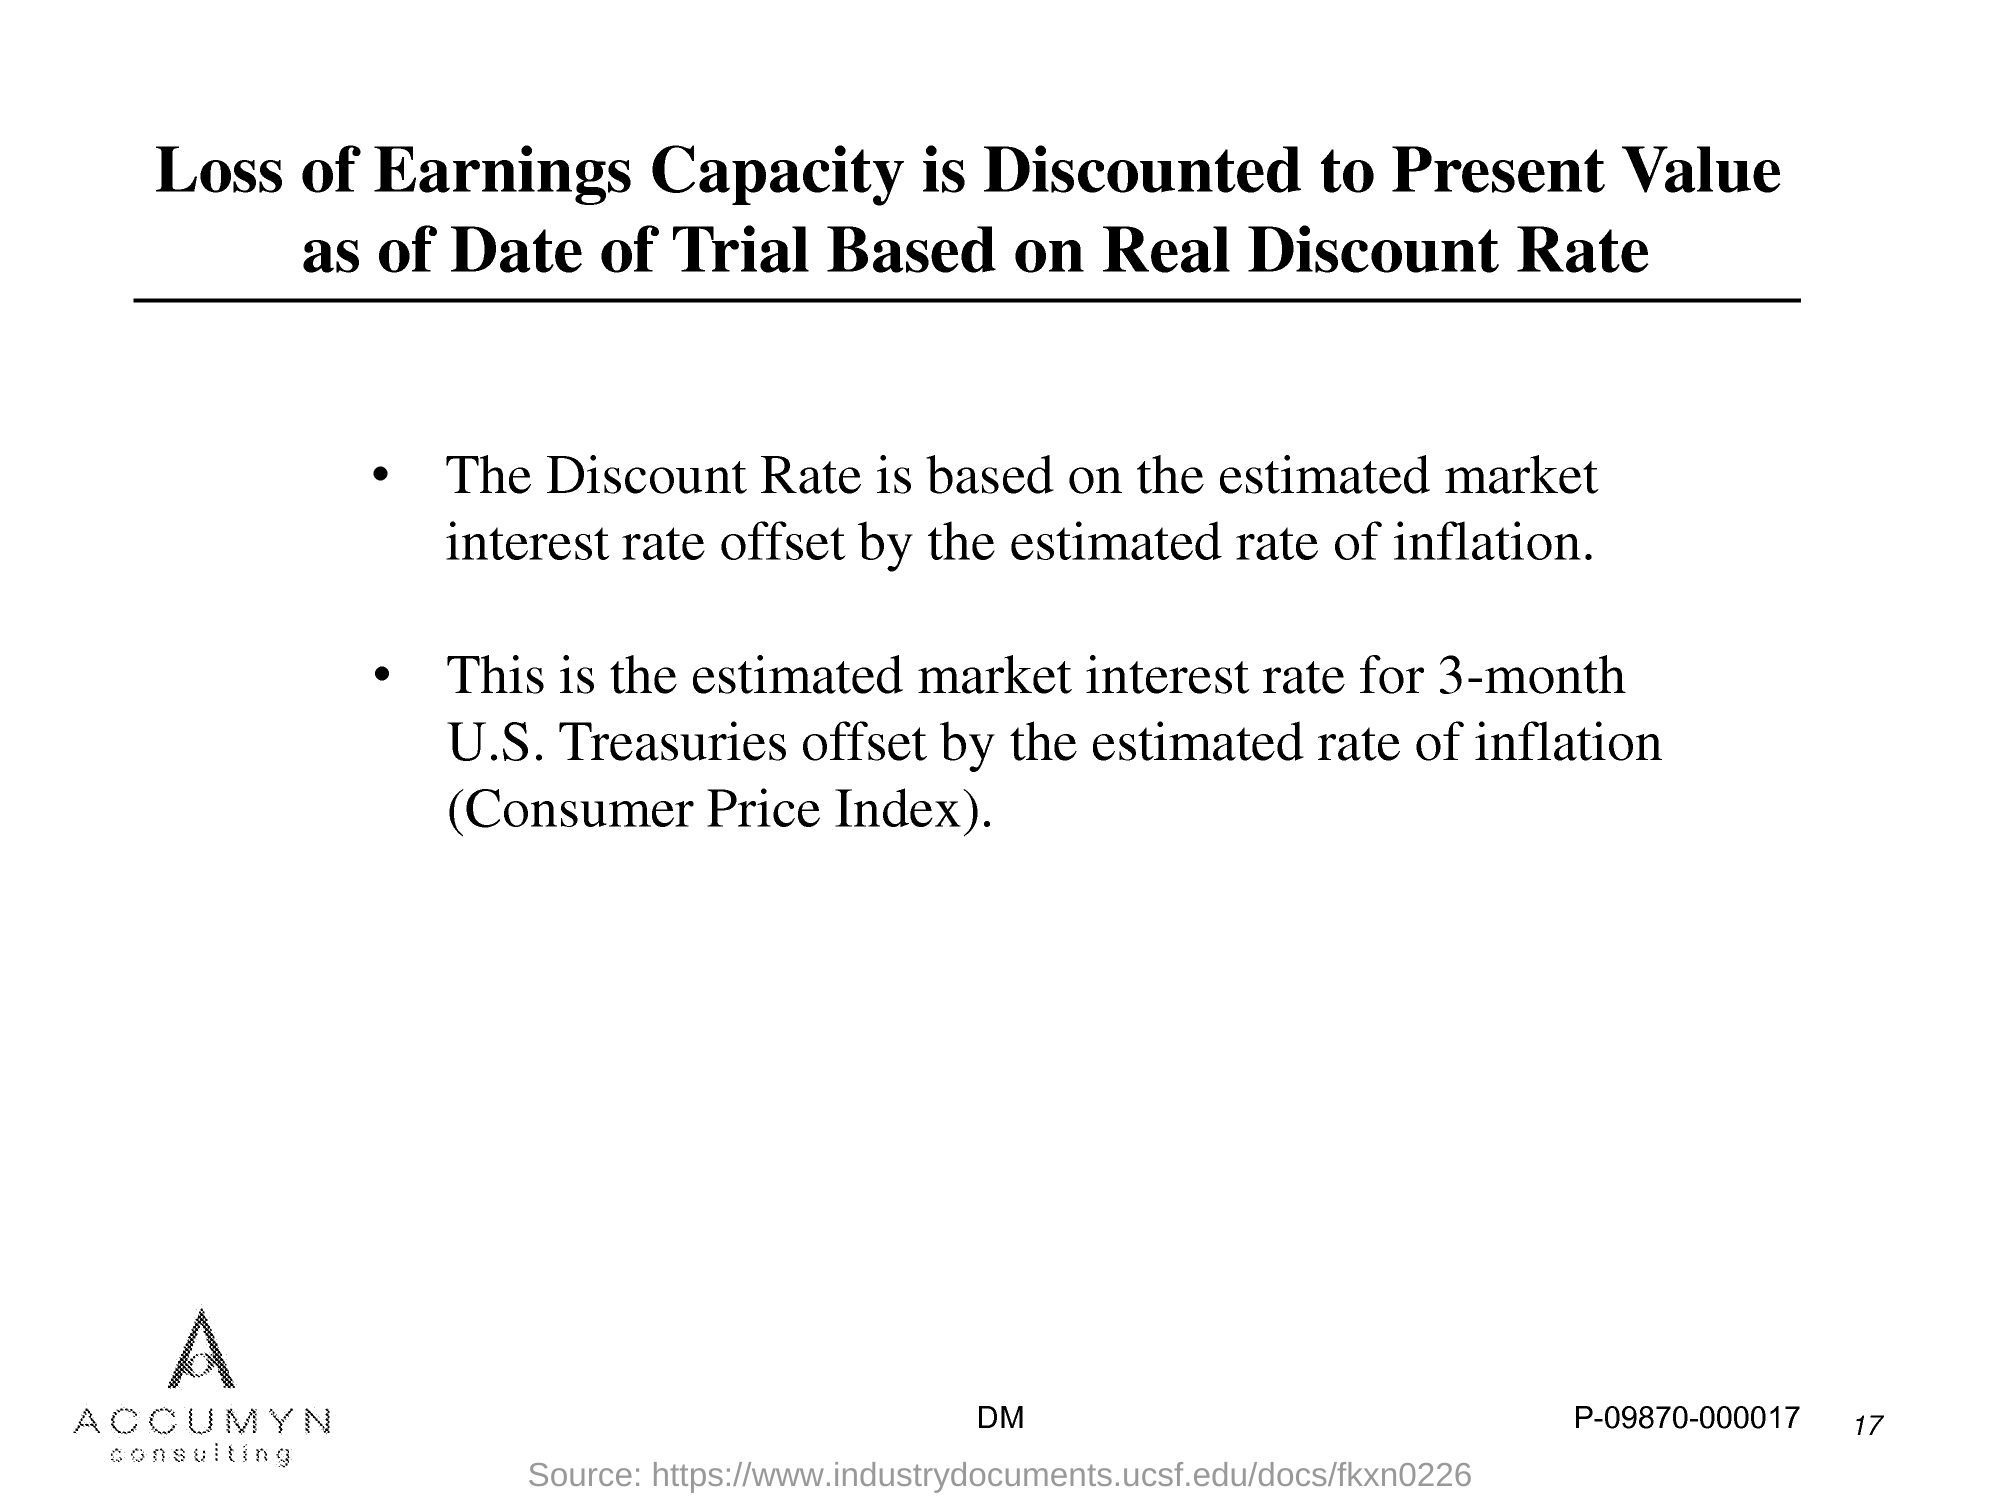Outline some significant characteristics in this image. The page number is 17. 